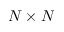<formula> <loc_0><loc_0><loc_500><loc_500>N \times N</formula> 